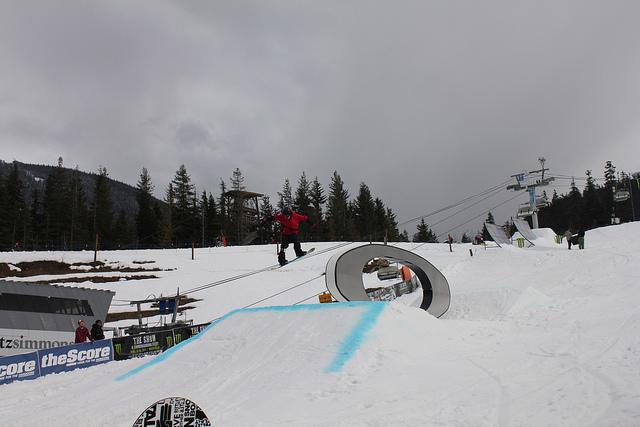Is this a ski jump?
Be succinct. Yes. Is it likely the wires in the distance are part of a ski lift?
Write a very short answer. Yes. What is on the ground?
Answer briefly. Snow. 